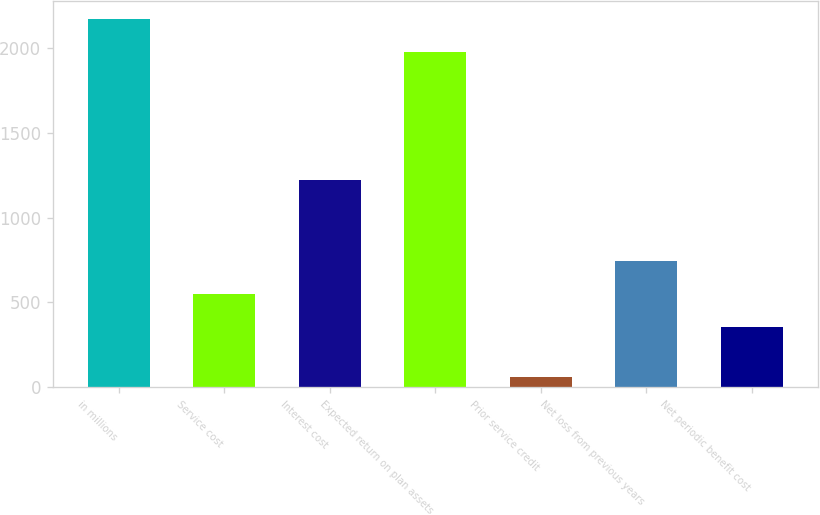Convert chart to OTSL. <chart><loc_0><loc_0><loc_500><loc_500><bar_chart><fcel>in millions<fcel>Service cost<fcel>Interest cost<fcel>Expected return on plan assets<fcel>Prior service credit<fcel>Net loss from previous years<fcel>Net periodic benefit cost<nl><fcel>2170.5<fcel>550.5<fcel>1224<fcel>1975<fcel>60<fcel>746<fcel>355<nl></chart> 